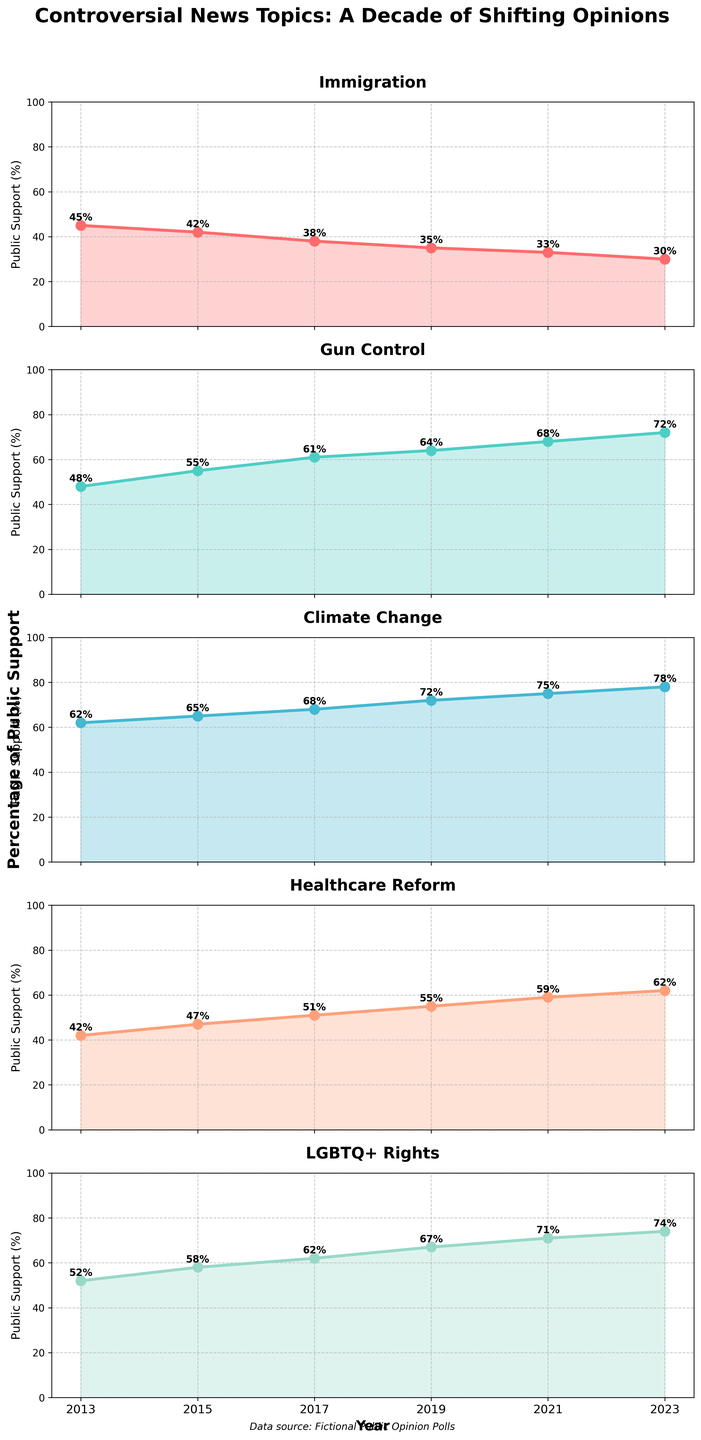How many data points are plotted for each topic? Each topic subplot shows data points for the years 2013, 2015, 2017, 2019, 2021, and 2023. That's a total of 6 data points per topic.
Answer: 6 Which topic shows the highest public support in 2023? In 2023, Climate Change shows the highest public support with a percentage of 78%.
Answer: Climate Change By how much has public support for Immigration decreased from 2013 to 2023? In 2013, support for Immigration was 45%, and in 2023 it is 30%. The decrease is 45% - 30% = 15%.
Answer: 15% Which topic experienced the greatest increase in public support over the decade? Climate Change increased from 62% in 2013 to 78% in 2023. The increase is 16%, which is higher than the increase for any other topic.
Answer: Climate Change Compare public support trends for Gun Control and Healthcare Reform in 2021. Which one had more support, and by how much? In 2021, Gun Control had a support of 68%, whereas Healthcare Reform had 59%. Gun Control had 68% - 59% = 9% more support than Healthcare Reform.
Answer: Gun Control by 9% In which year did Healthcare Reform see the greatest increase in public support compared to the previous data point? Healthcare Reform increased from 47% in 2015 to 51% in 2017. This increase of 51% - 47% = 4% is the largest between consecutive years for Healthcare Reform.
Answer: 2017 How did the public support for LGBTQ+ Rights change from 2017 to 2023? In 2017, support for LGBTQ+ Rights was 62%, and it increased to 74% in 2023. The change was 74% - 62% = 12%.
Answer: Increased by 12% Which topic had the most stable public support trend, showing the least fluctuation over the decade? Immigration shows a steady decrease in support each year, indicating a consistent trend with less fluctuation compared to the other topics.
Answer: Immigration What was the average public support for Climate Change from 2013 to 2023? Sum the percentages for Climate Change from each year: 62 + 65 + 68 + 72 + 75 + 78 = 420. There are 6 data points, so the average is 420 / 6 = 70%.
Answer: 70% By what percentage did support for Gun Control increase from its lowest to its highest point over the decade? The lowest support for Gun Control was 48% in 2013, and the highest was 72% in 2023. The increase is 72% - 48% = 24%.
Answer: 24% 